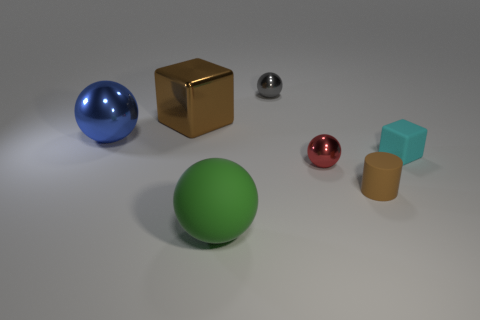Add 2 big metallic spheres. How many objects exist? 9 Subtract all cubes. How many objects are left? 5 Add 6 tiny cyan rubber blocks. How many tiny cyan rubber blocks exist? 7 Subtract 0 purple cubes. How many objects are left? 7 Subtract all gray objects. Subtract all tiny purple objects. How many objects are left? 6 Add 1 brown shiny cubes. How many brown shiny cubes are left? 2 